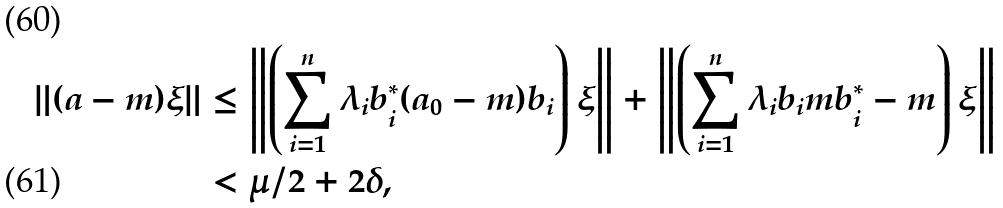<formula> <loc_0><loc_0><loc_500><loc_500>\| ( a - m ) \xi \| & \leq \left \| \left ( \sum _ { i = 1 } ^ { n } \lambda _ { i } b _ { i } ^ { * } ( a _ { 0 } - m ) b _ { i } \right ) \xi \right \| + \left \| \left ( \sum _ { i = 1 } ^ { n } \lambda _ { i } b _ { i } m b _ { i } ^ { * } - m \right ) \xi \right \| \\ & < \mu / 2 + 2 \delta ,</formula> 